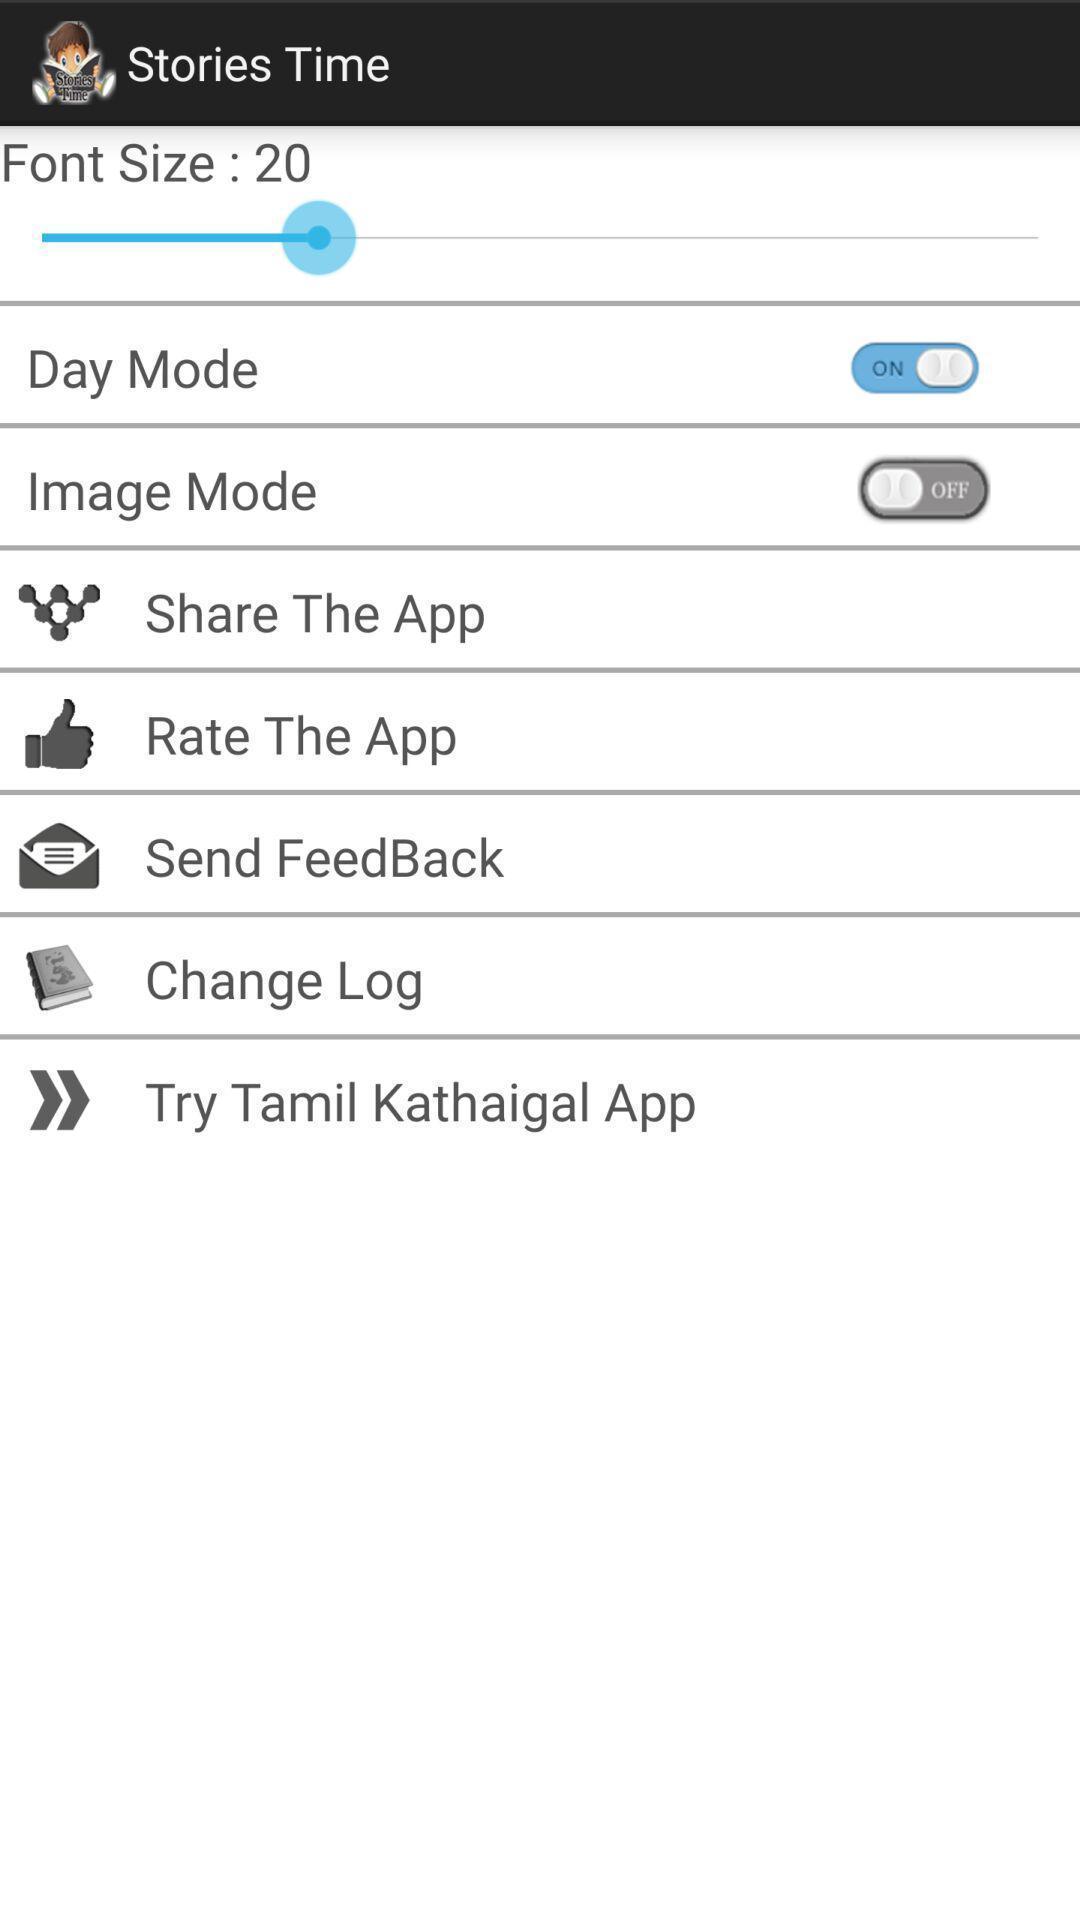Provide a textual representation of this image. Settings page of a stories app. 